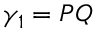Convert formula to latex. <formula><loc_0><loc_0><loc_500><loc_500>\gamma _ { 1 } = P Q</formula> 